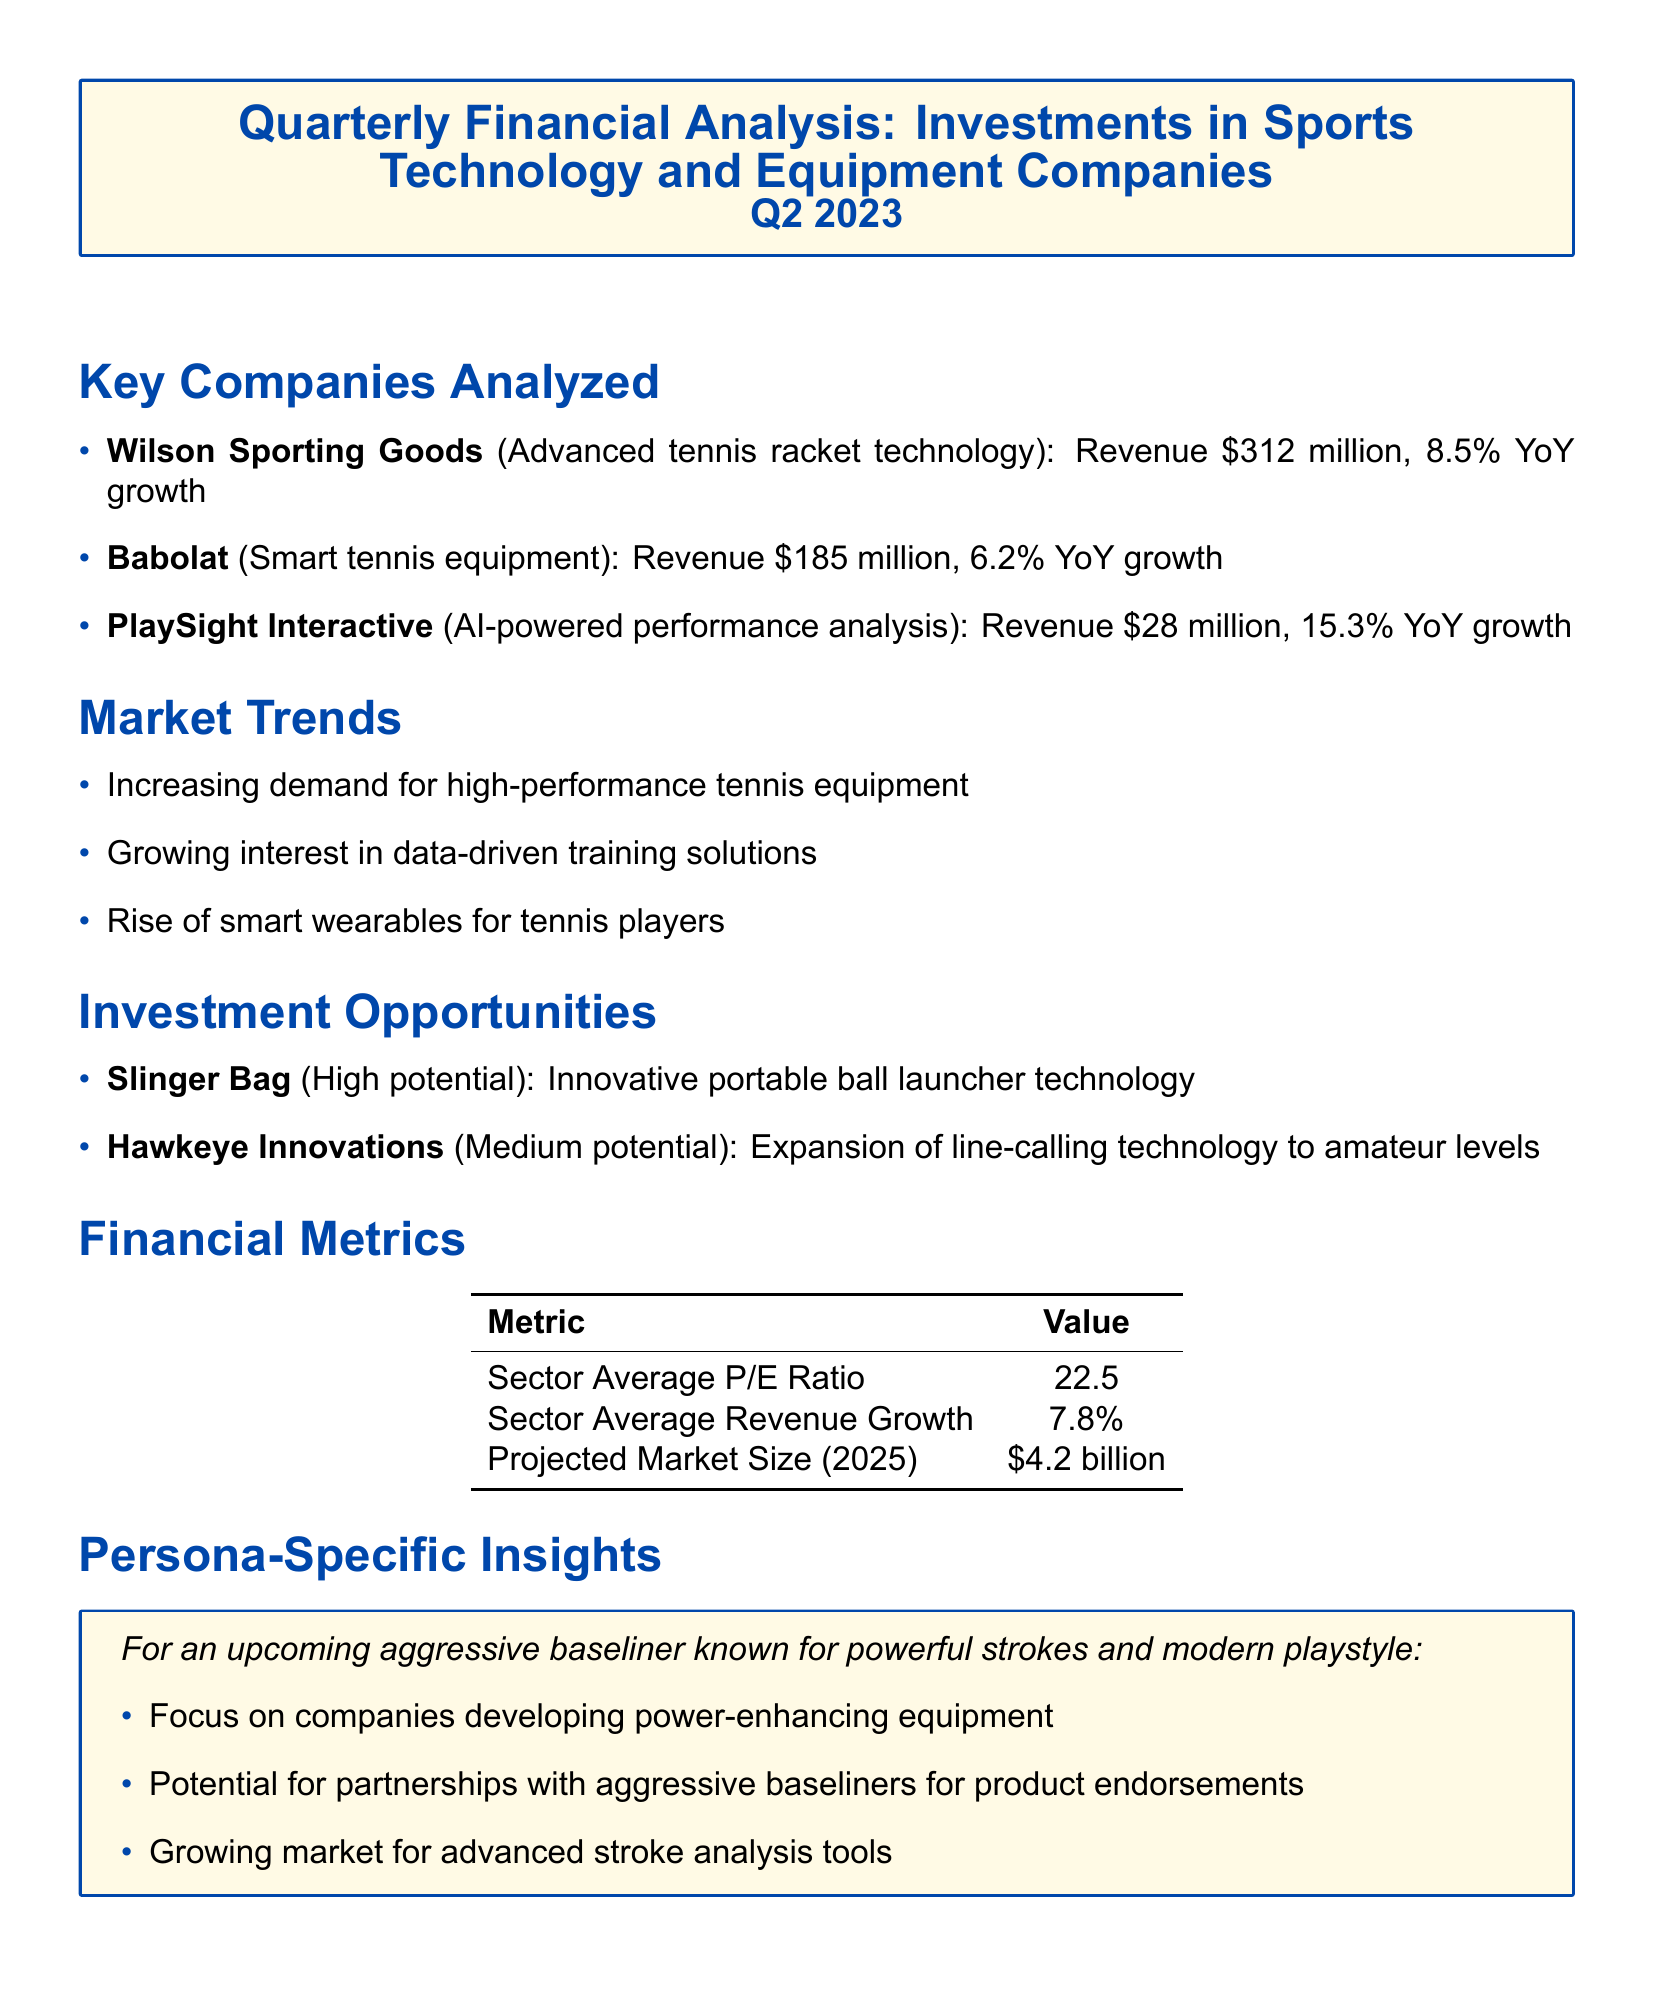what was the revenue of Wilson Sporting Goods? The revenue of Wilson Sporting Goods, as stated in the document, is $312 million.
Answer: $312 million what is the year-over-year growth for Babolat? The document specifies that Babolat has a year-over-year growth of 6.2%.
Answer: 6.2% YoY which company focuses on AI-powered performance analysis? According to the document, PlaySight Interactive focuses on AI-powered performance analysis.
Answer: PlaySight Interactive what is the projected market size for sports technology in 2025? The projected market size for sports technology in 2025 is mentioned as $4.2 billion.
Answer: $4.2 billion what type of technology does Slinger Bag provide? The document states that Slinger Bag offers an innovative portable ball launcher technology.
Answer: Innovative portable ball launcher technology which company has the highest revenue growth? PlaySight Interactive has the highest revenue growth at 15.3% YoY compared to others.
Answer: PlaySight Interactive what is the sector average P/E ratio? The sector average P/E ratio is listed as 22.5 in the financial metrics section.
Answer: 22.5 what market trend is driving interest in training solutions? The growing interest in data-driven training solutions is driving the trend, as per the document.
Answer: Growing interest in data-driven training solutions what specific insight is pointed out for aggressive baseliners? The document highlights the focus on companies developing power-enhancing equipment for aggressive baseliners.
Answer: Companies developing power-enhancing equipment 